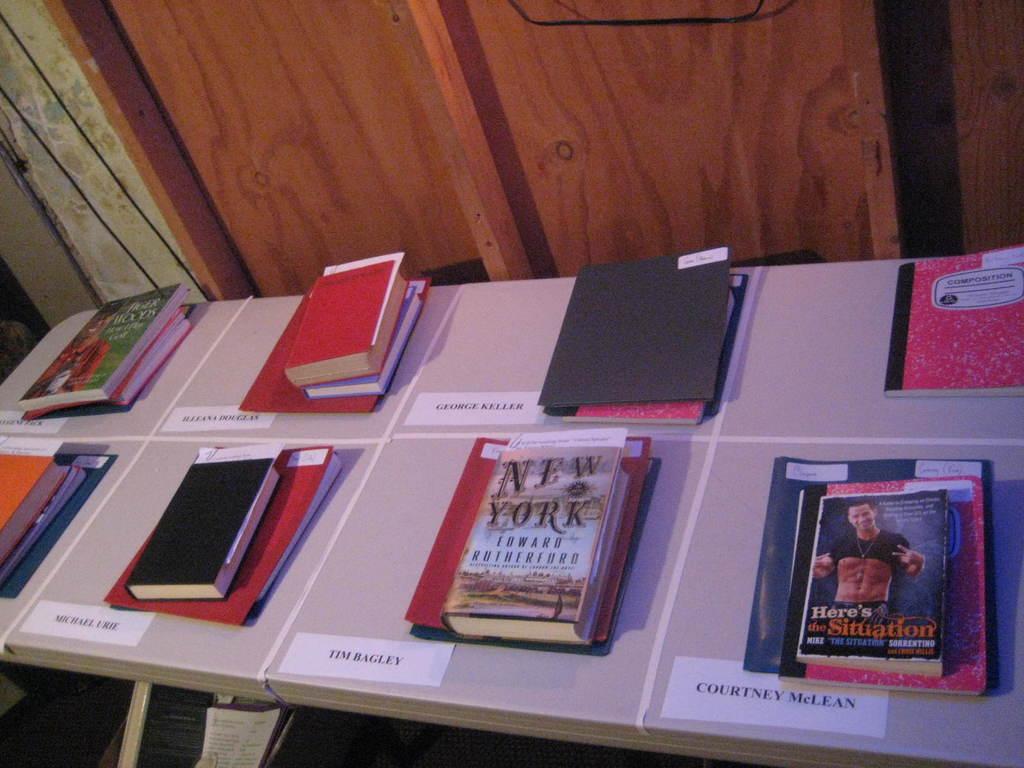Which reality tv star is featured in the book on the lower right?
Your response must be concise. The situation. What book is second from the right?
Your answer should be very brief. New york. 